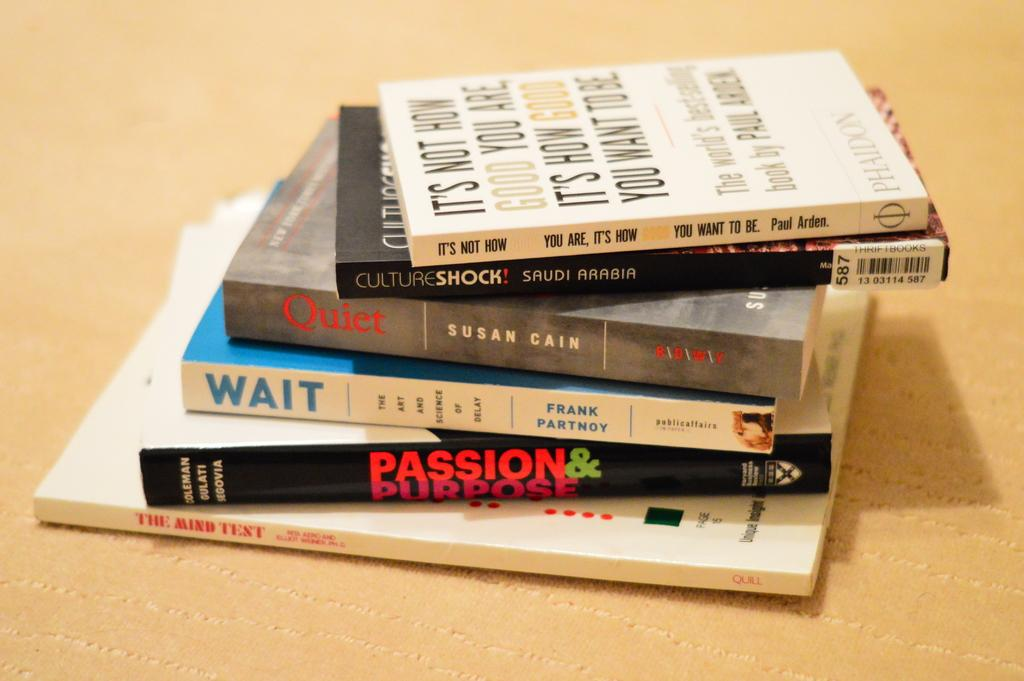<image>
Create a compact narrative representing the image presented. Six books are piled on the table, the last book is titled The Mind Test. 